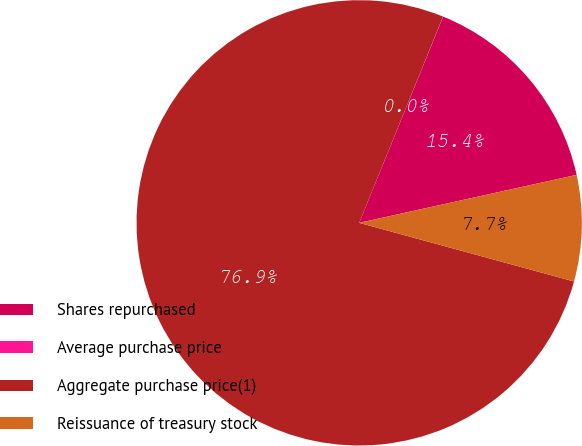Convert chart. <chart><loc_0><loc_0><loc_500><loc_500><pie_chart><fcel>Shares repurchased<fcel>Average purchase price<fcel>Aggregate purchase price(1)<fcel>Reissuance of treasury stock<nl><fcel>15.39%<fcel>0.01%<fcel>76.91%<fcel>7.7%<nl></chart> 